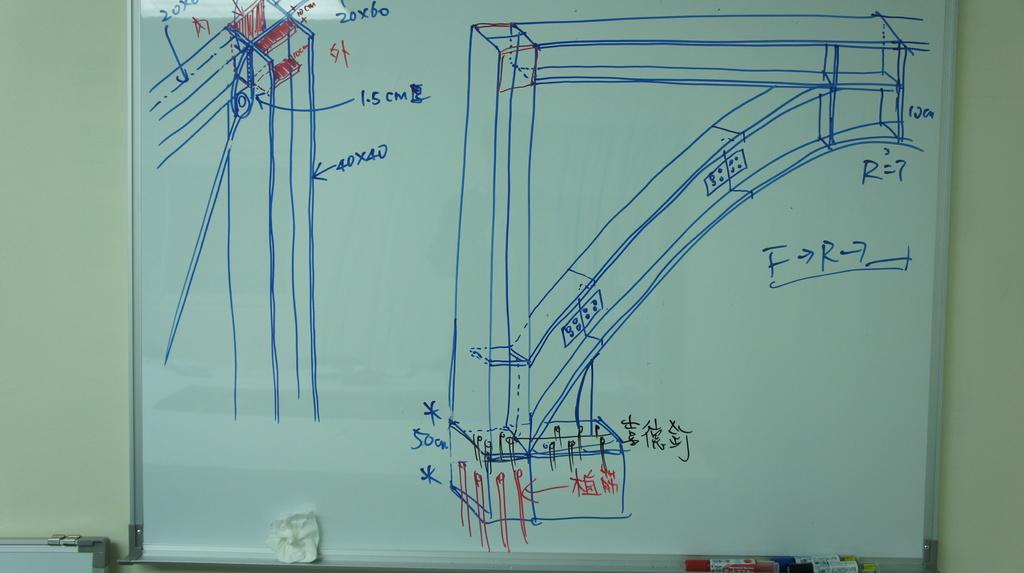<image>
Share a concise interpretation of the image provided. A whiteboard is covered with plans and numerical figures and measurements like 40x40. 